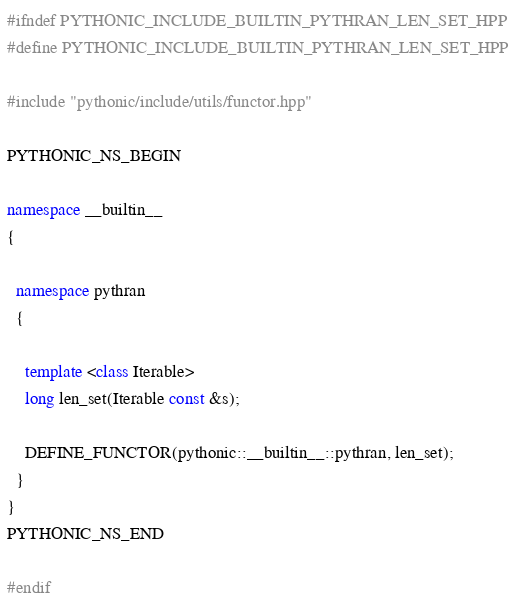<code> <loc_0><loc_0><loc_500><loc_500><_C++_>#ifndef PYTHONIC_INCLUDE_BUILTIN_PYTHRAN_LEN_SET_HPP
#define PYTHONIC_INCLUDE_BUILTIN_PYTHRAN_LEN_SET_HPP

#include "pythonic/include/utils/functor.hpp"

PYTHONIC_NS_BEGIN

namespace __builtin__
{

  namespace pythran
  {

    template <class Iterable>
    long len_set(Iterable const &s);

    DEFINE_FUNCTOR(pythonic::__builtin__::pythran, len_set);
  }
}
PYTHONIC_NS_END

#endif
</code> 